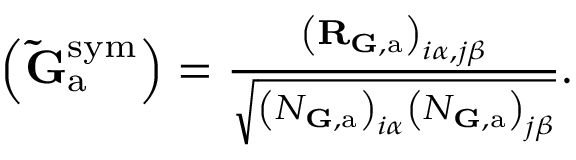<formula> <loc_0><loc_0><loc_500><loc_500>\begin{array} { r } { \left ( \tilde { G } _ { a } ^ { s y m } \right ) = \frac { \left ( R _ { { \mathbf G } , a } \right ) _ { i \alpha , j \beta } } { \sqrt { \left ( N _ { { \mathbf G } , a } \right ) _ { i \alpha } \left ( N _ { { \mathbf G } , a } \right ) _ { j \beta } } } . } \end{array}</formula> 